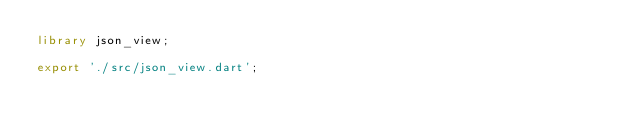Convert code to text. <code><loc_0><loc_0><loc_500><loc_500><_Dart_>library json_view;

export './src/json_view.dart';
</code> 